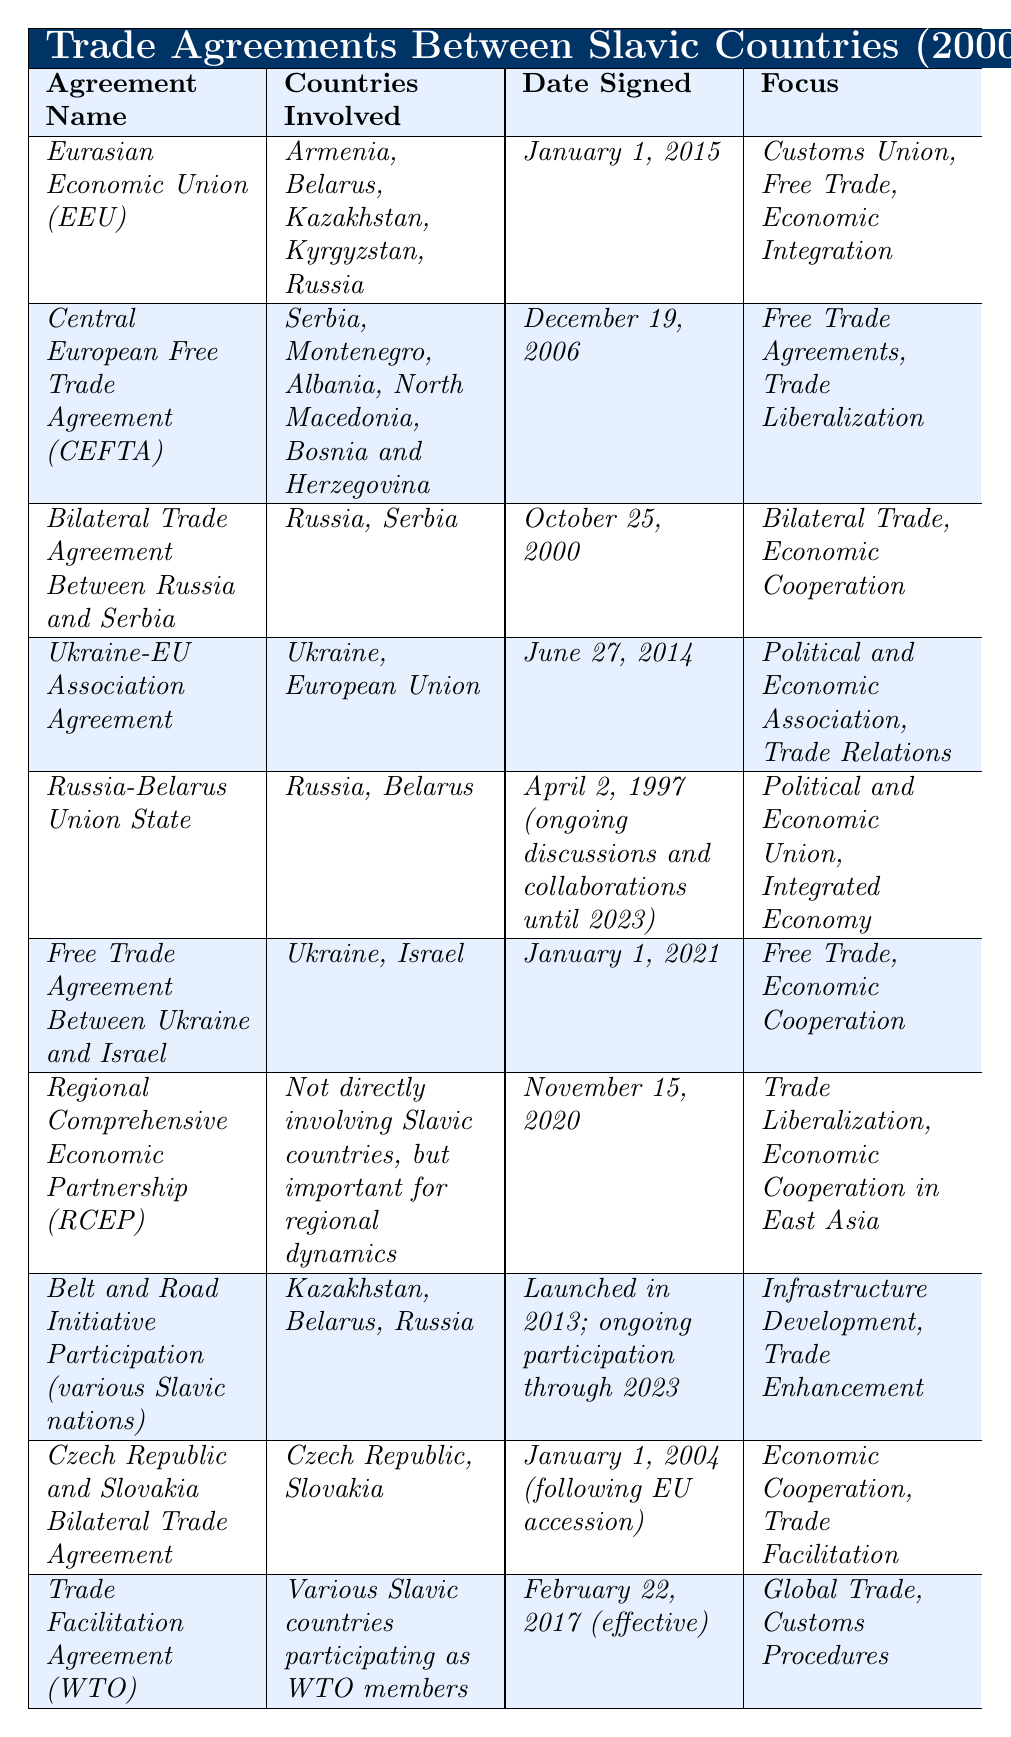What is the name of the trade agreement signed on January 1, 2015? The agreement listed in the table with the date signed as January 1, 2015, is the "Eurasian Economic Union (EEU)."
Answer: Eurasian Economic Union (EEU) How many countries are involved in the "Belt and Road Initiative Participation"? The table indicates that "Belt and Road Initiative Participation" involves three countries: Kazakhstan, Belarus, and Russia.
Answer: 3 Is there a trade agreement between Ukraine and Israel? Yes, based on the table, there is a trade agreement titled "Free Trade Agreement Between Ukraine and Israel."
Answer: Yes What are the focus areas of the "Trade Facilitation Agreement (WTO)"? The table shows that the focus areas of the "Trade Facilitation Agreement (WTO)" include "Global Trade" and "Customs Procedures."
Answer: Global Trade, Customs Procedures Which trade agreement was signed first: the "Bilateral Trade Agreement Between Russia and Serbia" or the "Czech Republic and Slovakia Bilateral Trade Agreement"? The "Bilateral Trade Agreement Between Russia and Serbia" was signed on October 25, 2000, while the "Czech Republic and Slovakia Bilateral Trade Agreement" was signed on January 1, 2004. Therefore, the former was signed first.
Answer: Bilateral Trade Agreement Between Russia and Serbia How many trade agreements include Russia? By inspecting the table, we see that Russia is involved in five trade agreements: EEU, Bilateral Trade Agreement with Serbia, Russia-Belarus Union State, Belt and Road Initiative Participation, and Trade Facilitation Agreement (WTO).
Answer: 5 Which agreement involves the European Union and when was it signed? The "Ukraine-EU Association Agreement" involves the European Union and was signed on June 27, 2014.
Answer: Ukraine-EU Association Agreement, June 27, 2014 Are there any agreements that focus on trade liberalization? Yes, the "Central European Free Trade Agreement (CEFTA)" and "Regional Comprehensive Economic Partnership (RCEP)" focus on trade liberalization according to the table.
Answer: Yes What is the overall focus of the "Russia-Belarus Union State"? The table indicates that the focus of the "Russia-Belarus Union State" is on "Political and Economic Union" and "Integrated Economy."
Answer: Political and Economic Union, Integrated Economy Which agreements were signed after 2015? The agreements "Free Trade Agreement Between Ukraine and Israel" (January 1, 2021) and "Trade Facilitation Agreement (WTO)" (February 22, 2017) were signed after 2015, as indicated in the table.
Answer: 2 Calculate the time difference between the signing of the "Bilateral Trade Agreement Between Russia and Serbia" and the "Eurasian Economic Union (EEU)." The "Bilateral Trade Agreement Between Russia and Serbia" was signed on October 25, 2000, and the "Eurasian Economic Union (EEU)" was signed on January 1, 2015. The difference is 14 years and a bit over 2 months.
Answer: 14 years 